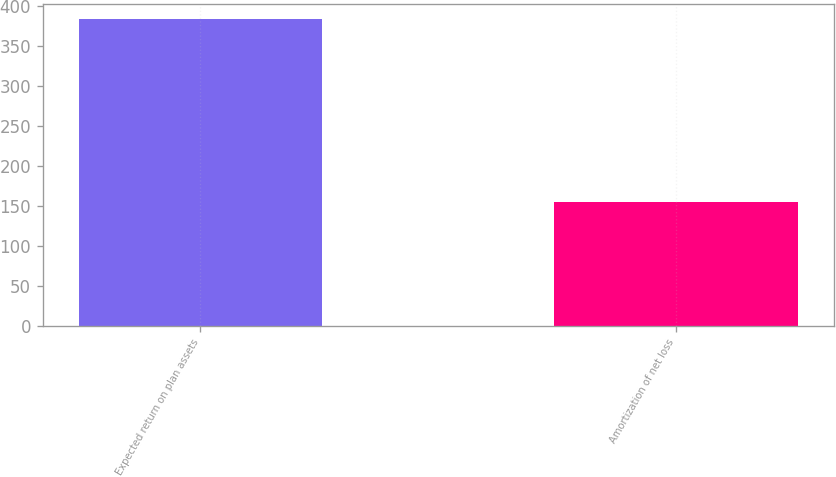Convert chart. <chart><loc_0><loc_0><loc_500><loc_500><bar_chart><fcel>Expected return on plan assets<fcel>Amortization of net loss<nl><fcel>384<fcel>155<nl></chart> 